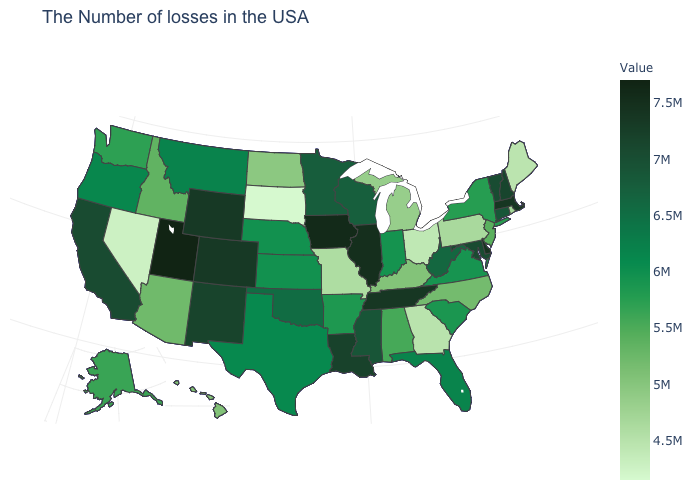Among the states that border Colorado , which have the lowest value?
Give a very brief answer. Arizona. Which states hav the highest value in the Northeast?
Keep it brief. Massachusetts. Does the map have missing data?
Quick response, please. No. Does the map have missing data?
Write a very short answer. No. Does Oklahoma have a higher value than Nevada?
Short answer required. Yes. 